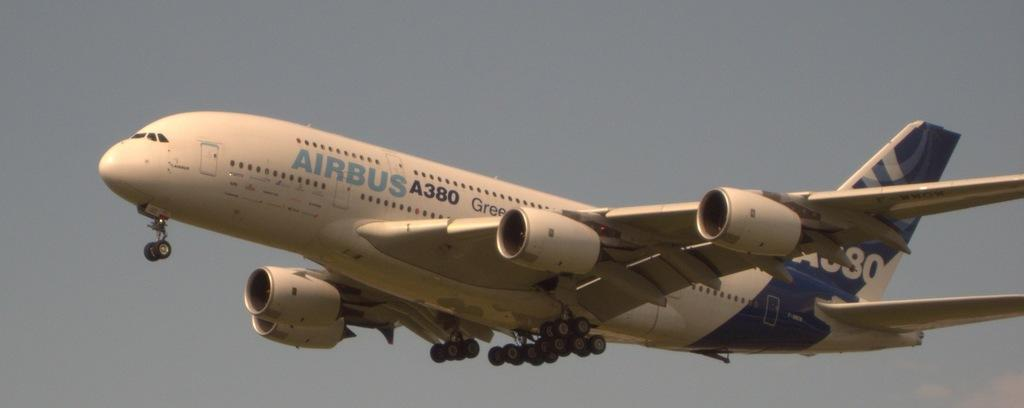<image>
Write a terse but informative summary of the picture. an Airbus A380 jet just after taking off into the air 